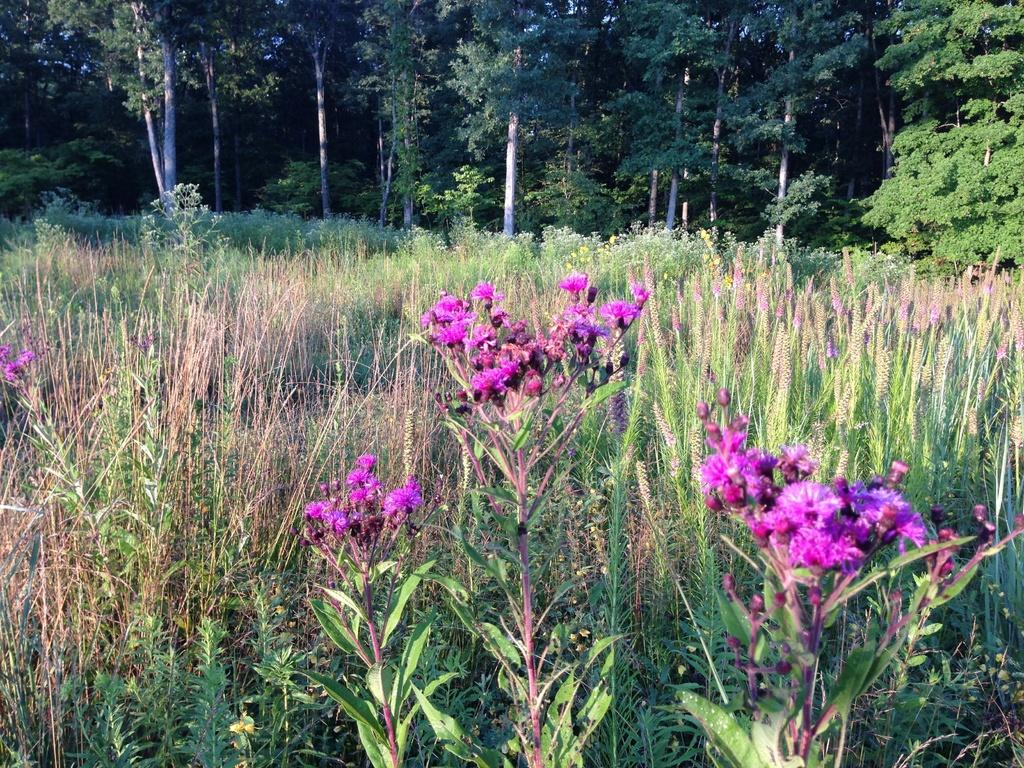What type of flora can be seen in the image? There are flowers and plants in the image. Can you describe the background of the image? There are trees in the background of the image. What type of advertisement is being displayed by the father in the image? There is no father or advertisement present in the image. 